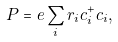Convert formula to latex. <formula><loc_0><loc_0><loc_500><loc_500>P = e \sum _ { i } r _ { i } c _ { i } ^ { + } c _ { i } ,</formula> 